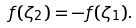Convert formula to latex. <formula><loc_0><loc_0><loc_500><loc_500>f ( \zeta _ { 2 } ) = - f ( \zeta _ { 1 } ) .</formula> 